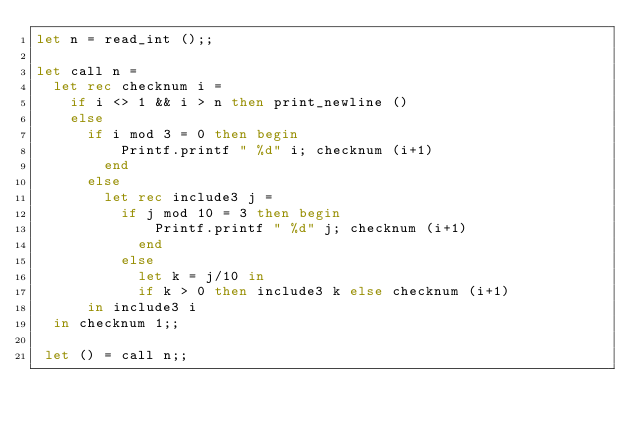Convert code to text. <code><loc_0><loc_0><loc_500><loc_500><_OCaml_>let n = read_int ();;

let call n =
  let rec checknum i =
    if i <> 1 && i > n then print_newline ()
    else
      if i mod 3 = 0 then begin
          Printf.printf " %d" i; checknum (i+1)
        end
      else
        let rec include3 j =
          if j mod 10 = 3 then begin
              Printf.printf " %d" j; checknum (i+1)
            end
          else
            let k = j/10 in
            if k > 0 then include3 k else checknum (i+1)
      in include3 i
  in checknum 1;;

 let () = call n;;</code> 